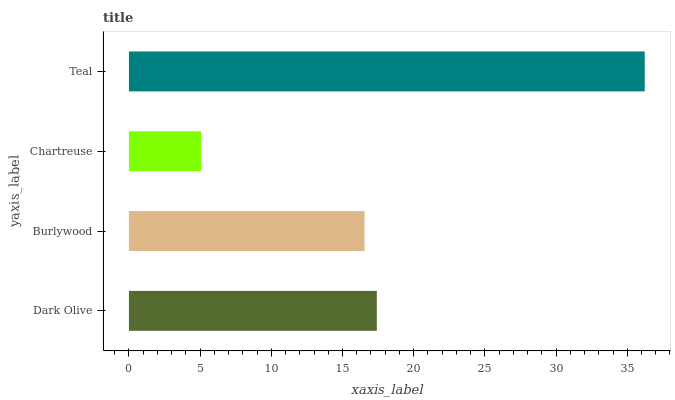Is Chartreuse the minimum?
Answer yes or no. Yes. Is Teal the maximum?
Answer yes or no. Yes. Is Burlywood the minimum?
Answer yes or no. No. Is Burlywood the maximum?
Answer yes or no. No. Is Dark Olive greater than Burlywood?
Answer yes or no. Yes. Is Burlywood less than Dark Olive?
Answer yes or no. Yes. Is Burlywood greater than Dark Olive?
Answer yes or no. No. Is Dark Olive less than Burlywood?
Answer yes or no. No. Is Dark Olive the high median?
Answer yes or no. Yes. Is Burlywood the low median?
Answer yes or no. Yes. Is Burlywood the high median?
Answer yes or no. No. Is Dark Olive the low median?
Answer yes or no. No. 